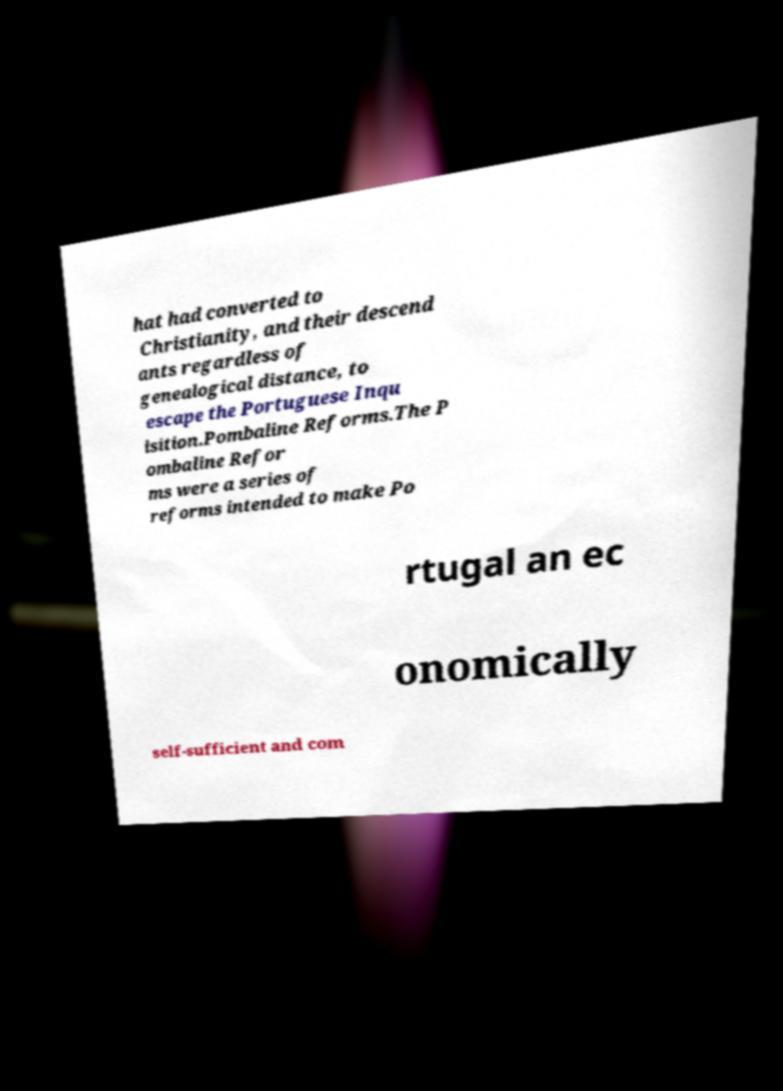Can you read and provide the text displayed in the image?This photo seems to have some interesting text. Can you extract and type it out for me? hat had converted to Christianity, and their descend ants regardless of genealogical distance, to escape the Portuguese Inqu isition.Pombaline Reforms.The P ombaline Refor ms were a series of reforms intended to make Po rtugal an ec onomically self-sufficient and com 